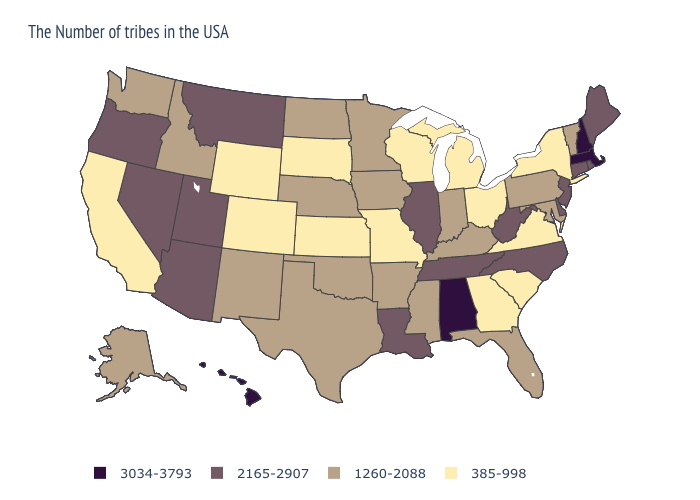What is the highest value in states that border South Dakota?
Short answer required. 2165-2907. Does the first symbol in the legend represent the smallest category?
Quick response, please. No. What is the value of Massachusetts?
Answer briefly. 3034-3793. Among the states that border Missouri , which have the highest value?
Short answer required. Tennessee, Illinois. What is the value of Nebraska?
Give a very brief answer. 1260-2088. Name the states that have a value in the range 1260-2088?
Keep it brief. Vermont, Maryland, Pennsylvania, Florida, Kentucky, Indiana, Mississippi, Arkansas, Minnesota, Iowa, Nebraska, Oklahoma, Texas, North Dakota, New Mexico, Idaho, Washington, Alaska. What is the value of Minnesota?
Keep it brief. 1260-2088. Does North Carolina have the highest value in the South?
Be succinct. No. Name the states that have a value in the range 385-998?
Write a very short answer. New York, Virginia, South Carolina, Ohio, Georgia, Michigan, Wisconsin, Missouri, Kansas, South Dakota, Wyoming, Colorado, California. Which states hav the highest value in the MidWest?
Concise answer only. Illinois. What is the value of Georgia?
Give a very brief answer. 385-998. What is the value of Nevada?
Give a very brief answer. 2165-2907. Name the states that have a value in the range 2165-2907?
Keep it brief. Maine, Rhode Island, Connecticut, New Jersey, Delaware, North Carolina, West Virginia, Tennessee, Illinois, Louisiana, Utah, Montana, Arizona, Nevada, Oregon. What is the lowest value in states that border Maine?
Answer briefly. 3034-3793. Does Alabama have the highest value in the USA?
Short answer required. Yes. 